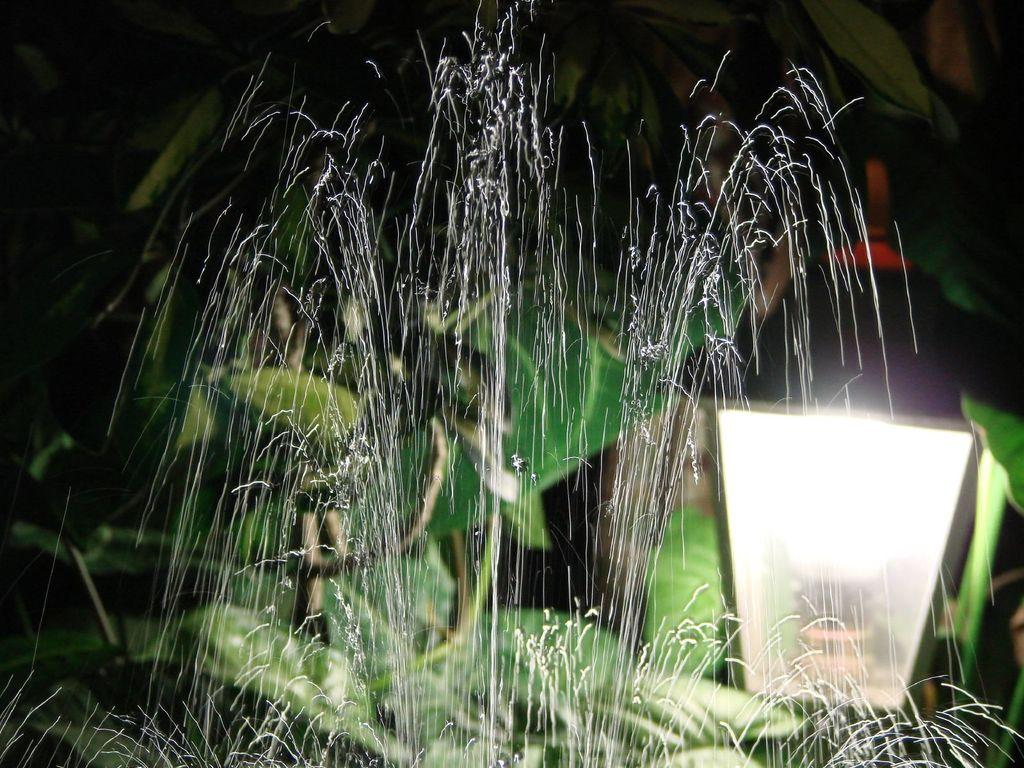What is visible in the image? There is water visible in the image. Can you describe the light in the image? There is a light in the front of the image. What type of vegetation can be seen in the background? There are green color leaves in the background of the image. How much profit can be made from the hill in the image? There is no hill present in the image, and therefore no profit can be made from it. What type of sorting is being done with the leaves in the image? There is no sorting activity involving the leaves in the image. 